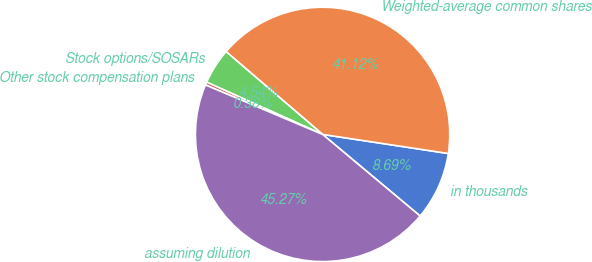Convert chart to OTSL. <chart><loc_0><loc_0><loc_500><loc_500><pie_chart><fcel>in thousands<fcel>Weighted-average common shares<fcel>Stock options/SOSARs<fcel>Other stock compensation plans<fcel>assuming dilution<nl><fcel>8.69%<fcel>41.12%<fcel>4.54%<fcel>0.38%<fcel>45.27%<nl></chart> 